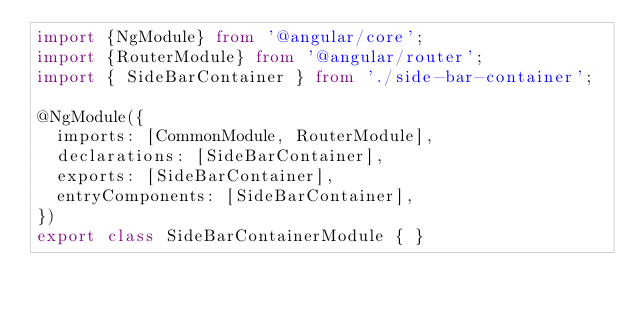<code> <loc_0><loc_0><loc_500><loc_500><_TypeScript_>import {NgModule} from '@angular/core';
import {RouterModule} from '@angular/router';
import { SideBarContainer } from './side-bar-container';

@NgModule({
  imports: [CommonModule, RouterModule],
  declarations: [SideBarContainer],
  exports: [SideBarContainer],
  entryComponents: [SideBarContainer],
})
export class SideBarContainerModule { }
</code> 